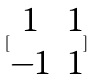Convert formula to latex. <formula><loc_0><loc_0><loc_500><loc_500>[ \begin{matrix} 1 & 1 \\ - 1 & 1 \end{matrix} ]</formula> 